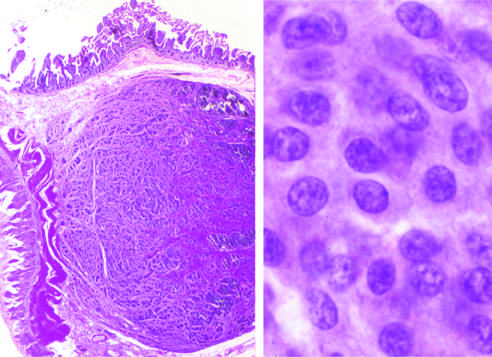what form a submucosal nodule composed of tumor cells embedded in dense fibrous tissue?
Answer the question using a single word or phrase. Carcinoid tumors 